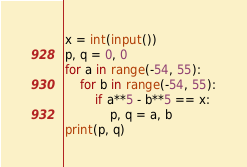Convert code to text. <code><loc_0><loc_0><loc_500><loc_500><_Python_>x = int(input())
p, q = 0, 0
for a in range(-54, 55):
    for b in range(-54, 55):
        if a**5 - b**5 == x:
            p, q = a, b
print(p, q)</code> 